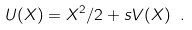<formula> <loc_0><loc_0><loc_500><loc_500>U ( X ) = X ^ { 2 } / 2 + s V ( X ) \ .</formula> 